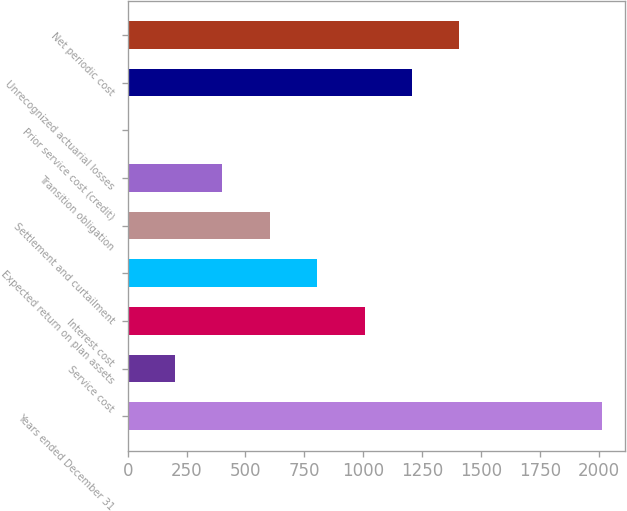<chart> <loc_0><loc_0><loc_500><loc_500><bar_chart><fcel>Years ended December 31<fcel>Service cost<fcel>Interest cost<fcel>Expected return on plan assets<fcel>Settlement and curtailment<fcel>Transition obligation<fcel>Prior service cost (credit)<fcel>Unrecognized actuarial losses<fcel>Net periodic cost<nl><fcel>2012<fcel>201.29<fcel>1006.05<fcel>804.86<fcel>603.67<fcel>402.48<fcel>0.1<fcel>1207.24<fcel>1408.43<nl></chart> 